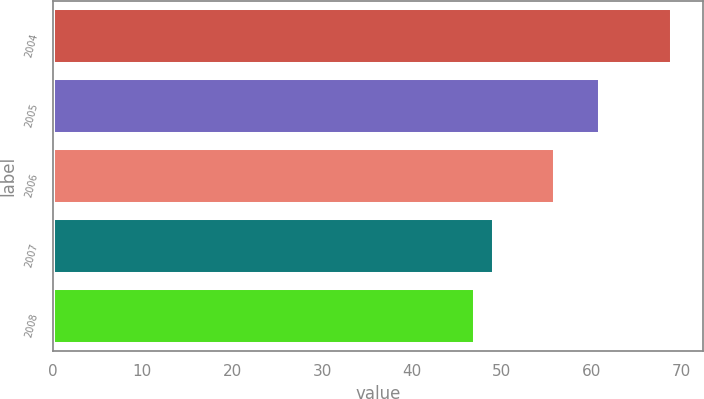Convert chart. <chart><loc_0><loc_0><loc_500><loc_500><bar_chart><fcel>2004<fcel>2005<fcel>2006<fcel>2007<fcel>2008<nl><fcel>69<fcel>61<fcel>56<fcel>49.2<fcel>47<nl></chart> 